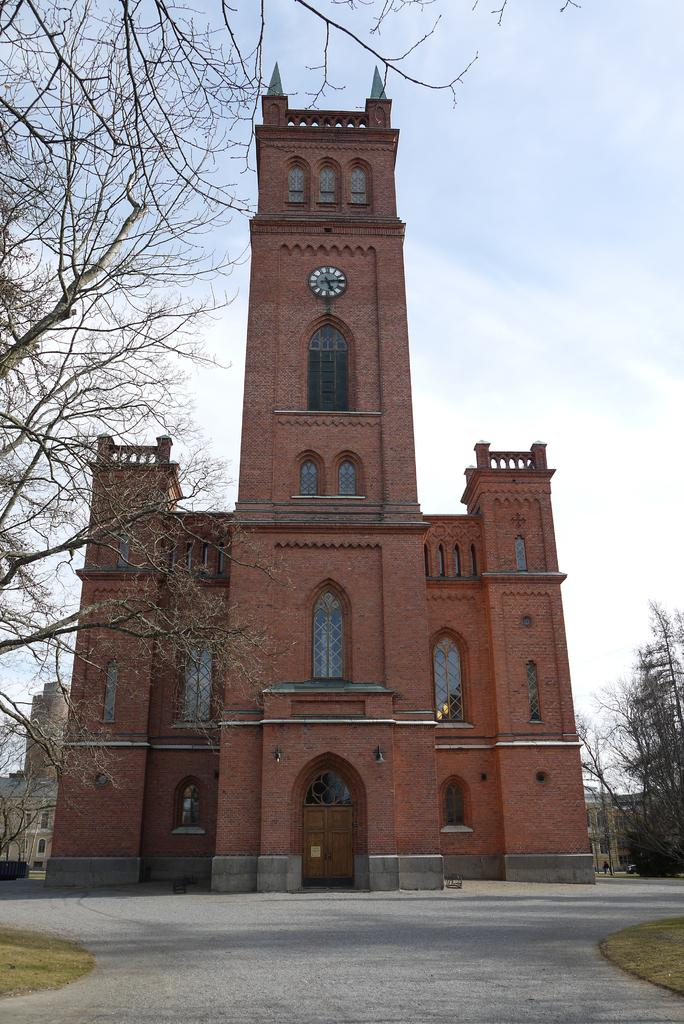What type of structure is present in the image? There is a building in the image. What information can be gathered from the building? The building displays an o'clock. Are there any other structures visible in the image? Yes, there are other buildings visible in the image. What type of natural elements can be seen in the image? There are trees in the image. How would you describe the sky in the image? The sky is blue and cloudy. Where is the coat hanging in the image? There is no coat present in the image. On which wrist is the tub located in the image? There is no wrist or tub present in the image. 